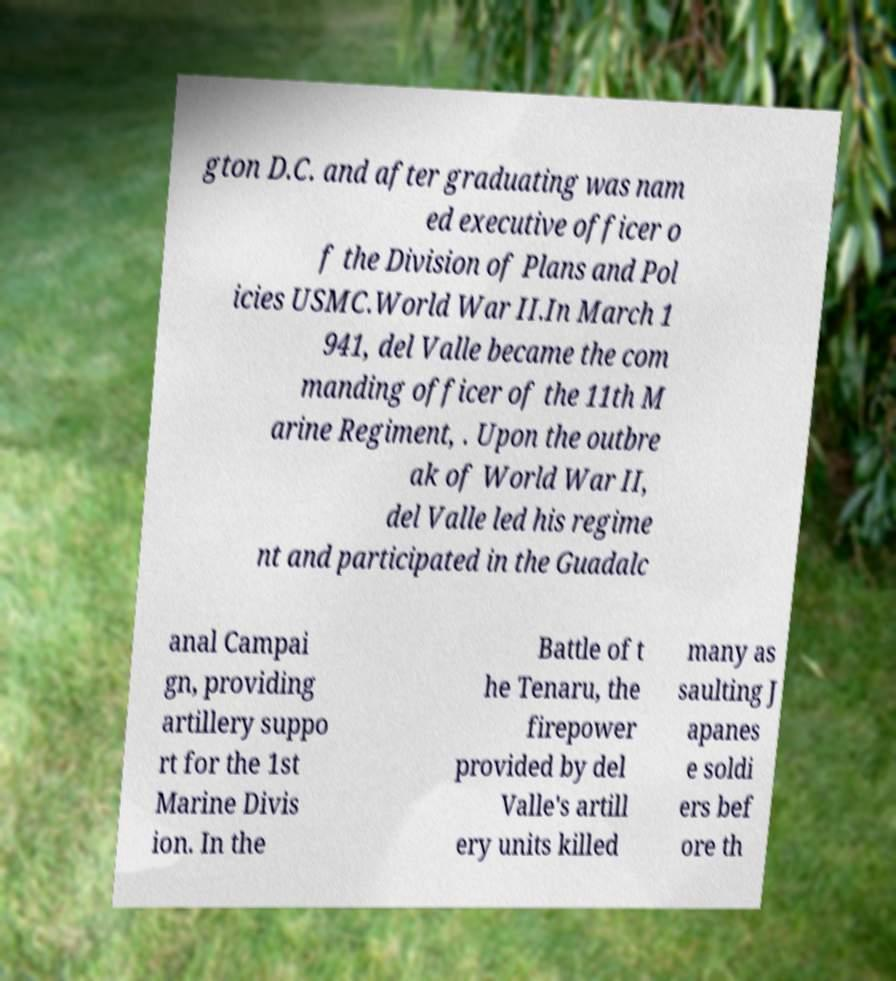Could you assist in decoding the text presented in this image and type it out clearly? gton D.C. and after graduating was nam ed executive officer o f the Division of Plans and Pol icies USMC.World War II.In March 1 941, del Valle became the com manding officer of the 11th M arine Regiment, . Upon the outbre ak of World War II, del Valle led his regime nt and participated in the Guadalc anal Campai gn, providing artillery suppo rt for the 1st Marine Divis ion. In the Battle of t he Tenaru, the firepower provided by del Valle's artill ery units killed many as saulting J apanes e soldi ers bef ore th 